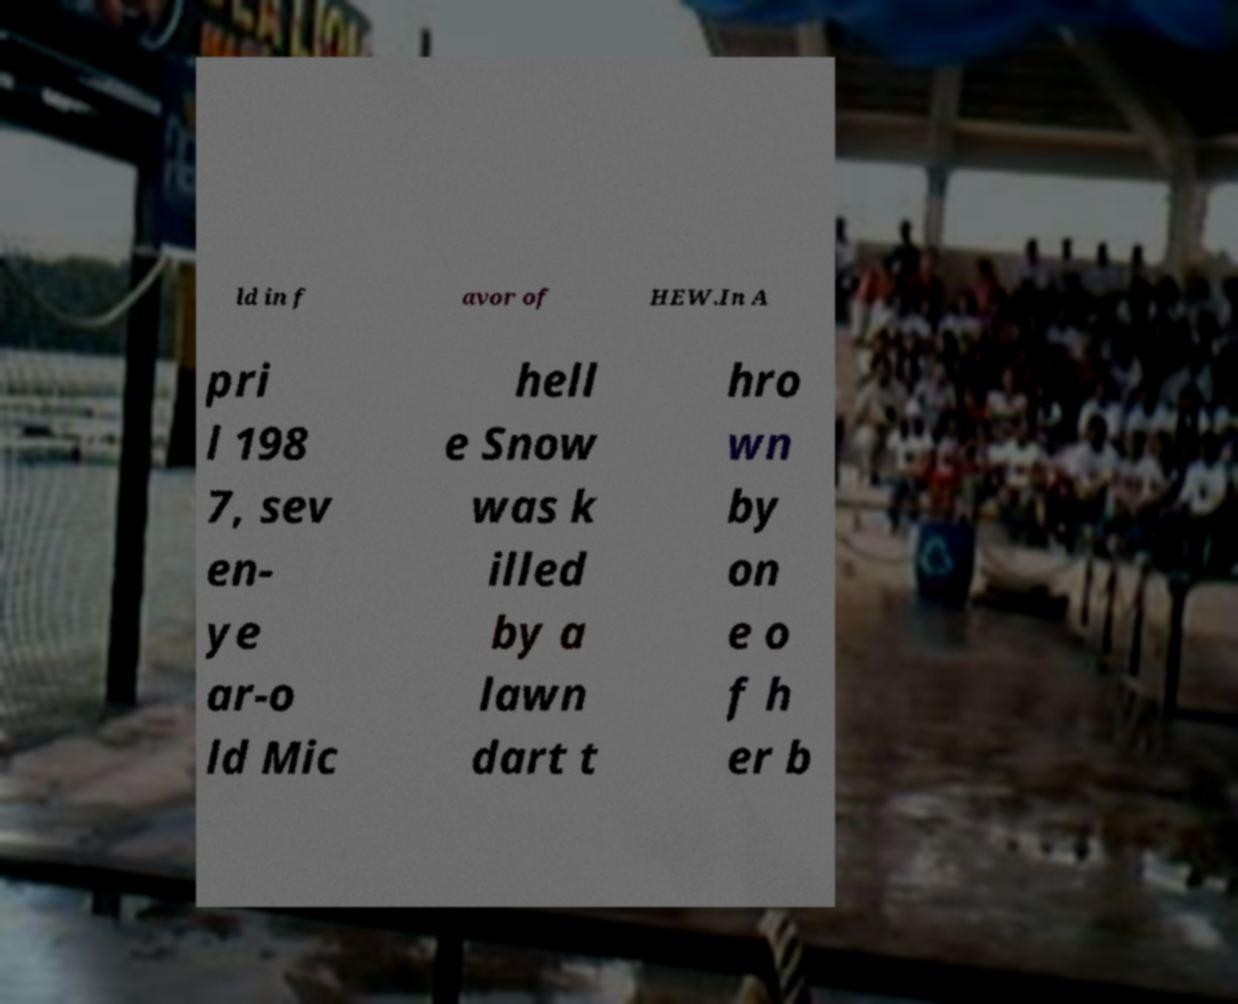What messages or text are displayed in this image? I need them in a readable, typed format. ld in f avor of HEW.In A pri l 198 7, sev en- ye ar-o ld Mic hell e Snow was k illed by a lawn dart t hro wn by on e o f h er b 